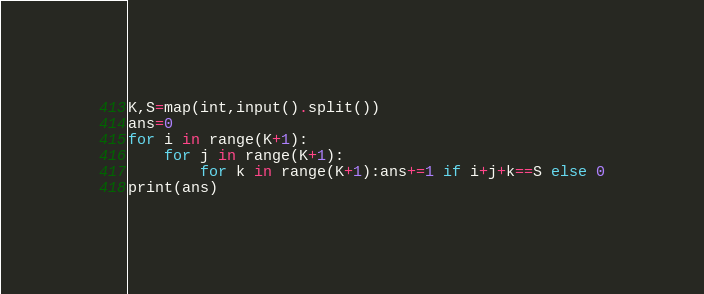<code> <loc_0><loc_0><loc_500><loc_500><_Python_>K,S=map(int,input().split())
ans=0
for i in range(K+1):
    for j in range(K+1):
        for k in range(K+1):ans+=1 if i+j+k==S else 0
print(ans)</code> 